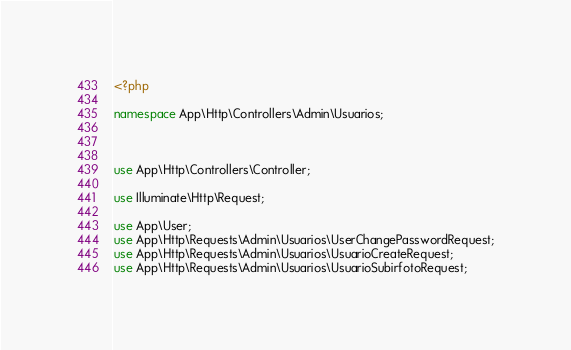<code> <loc_0><loc_0><loc_500><loc_500><_PHP_><?php

namespace App\Http\Controllers\Admin\Usuarios;



use App\Http\Controllers\Controller;

use Illuminate\Http\Request;

use App\User;
use App\Http\Requests\Admin\Usuarios\UserChangePasswordRequest;
use App\Http\Requests\Admin\Usuarios\UsuarioCreateRequest;
use App\Http\Requests\Admin\Usuarios\UsuarioSubirfotoRequest;</code> 